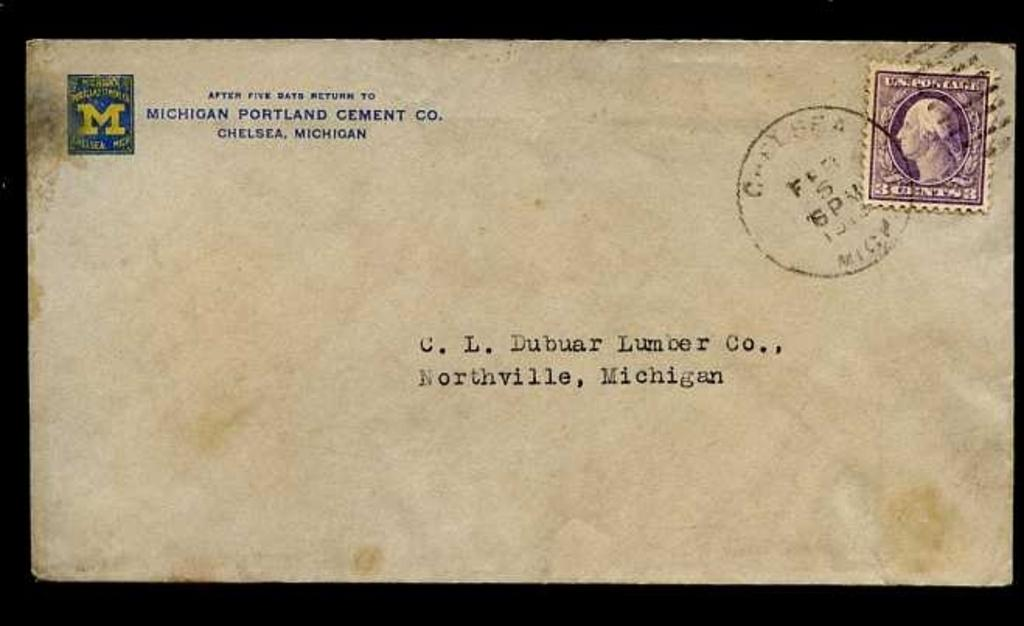<image>
Relay a brief, clear account of the picture shown. An old letter from Michigan Portland Cement Co. 